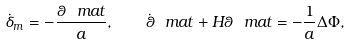<formula> <loc_0><loc_0><loc_500><loc_500>\dot { \delta } _ { m } = - \frac { \theta _ { \ } m a t } { a } , \quad \dot { \theta } _ { \ } m a t + H \theta _ { \ } m a t = - \frac { 1 } { a } \Delta \Phi ,</formula> 